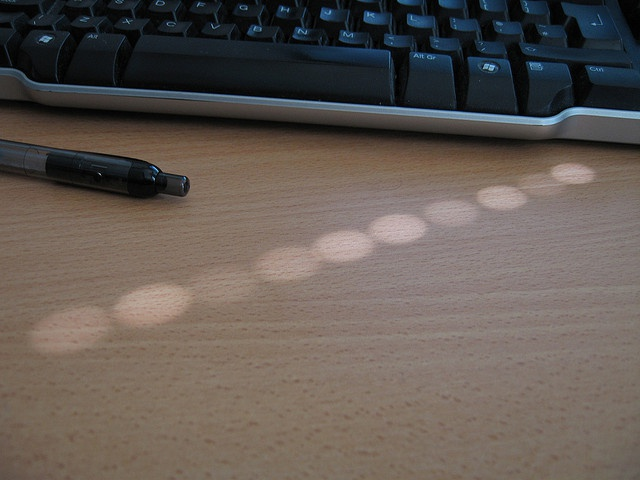Describe the objects in this image and their specific colors. I can see a keyboard in black, darkblue, gray, and blue tones in this image. 